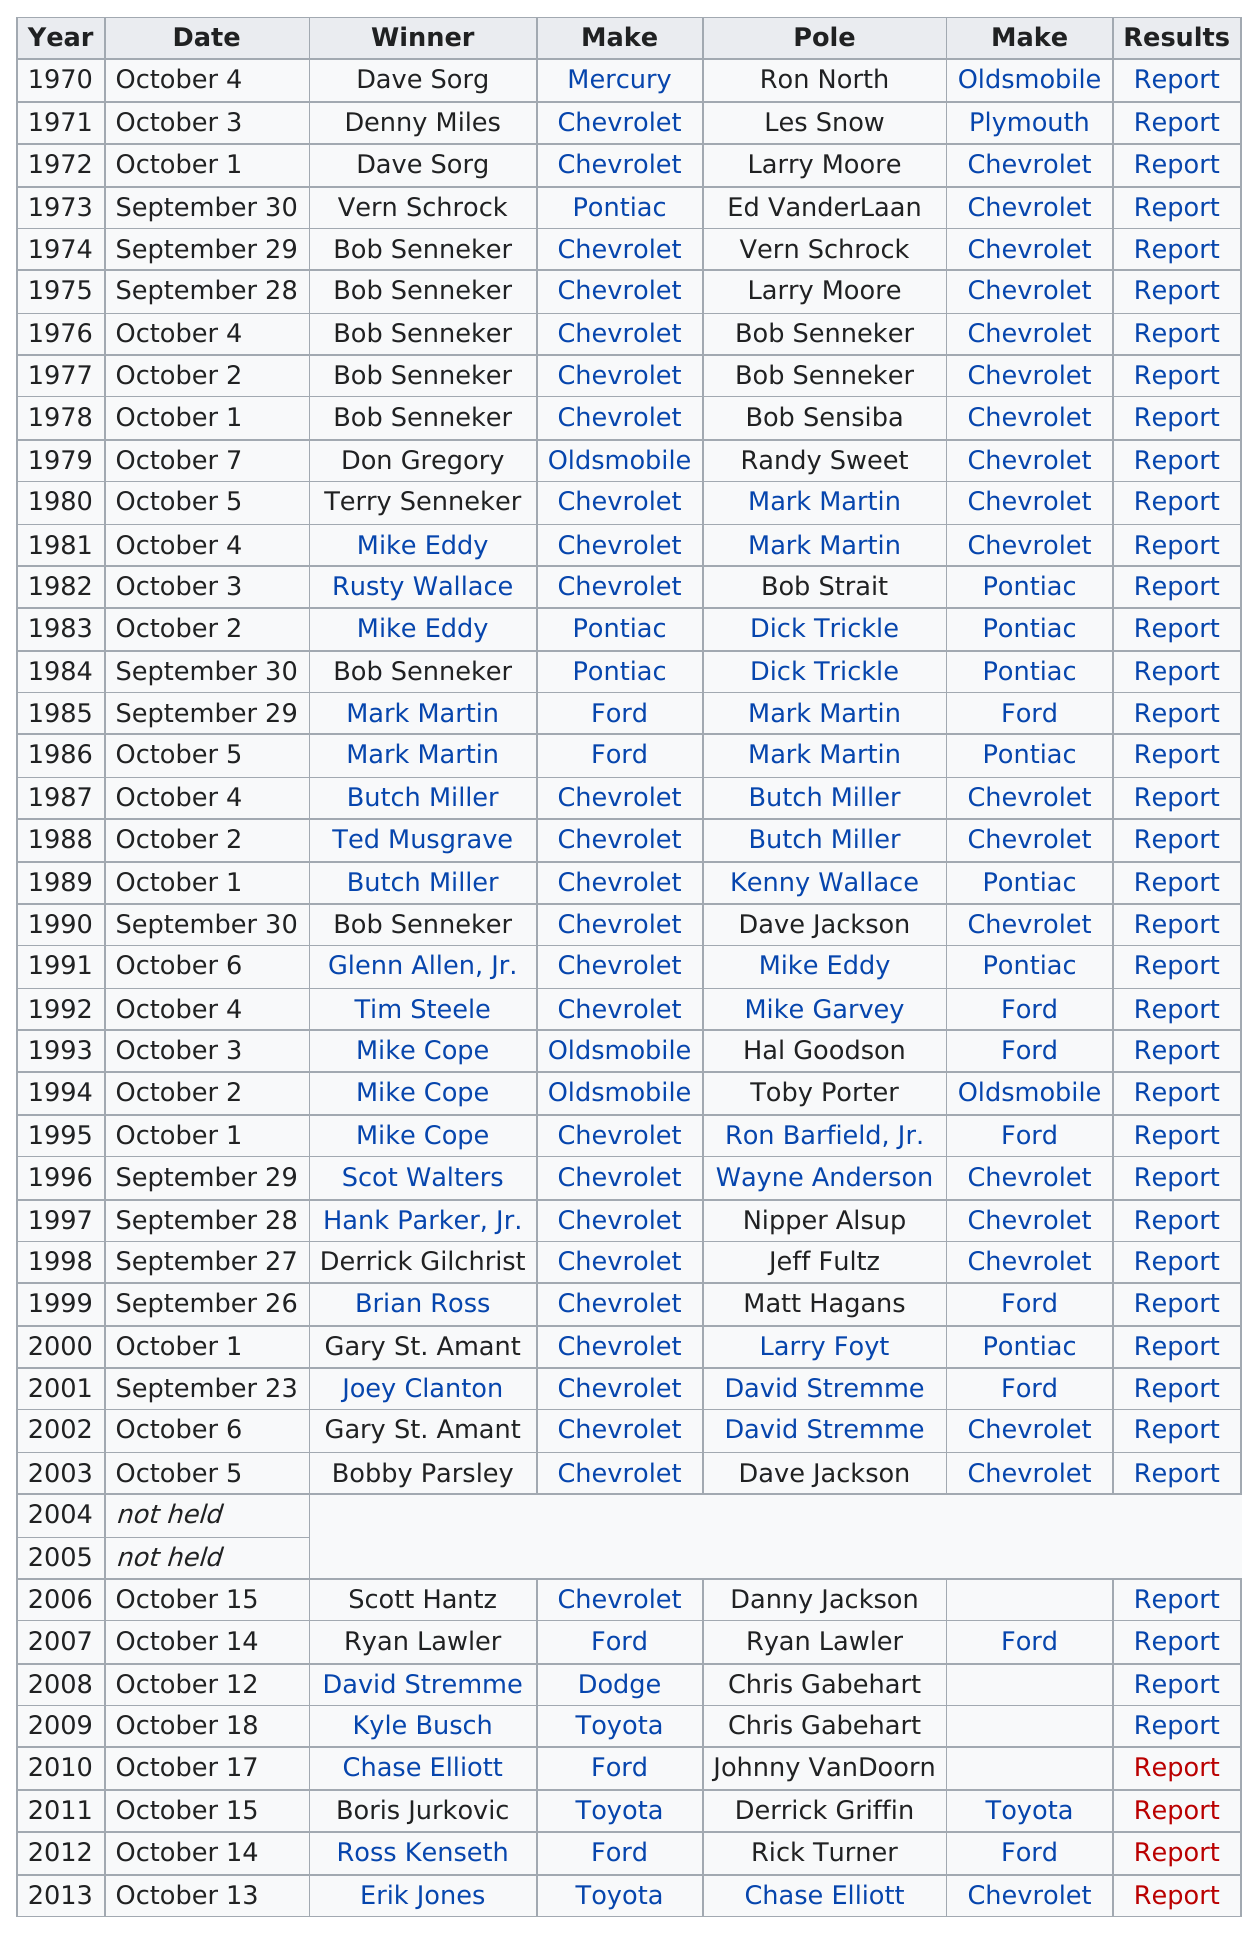Outline some significant characteristics in this image. In October, the most Winchester 400 races were held. How many times did Bob Senneker win in consecutive years? He won five times. Chevrolet has won the most total number of vehicles in the Winchester 400 race. According to the data, Toyota was the make of car that was used the least by those who won races. The player listed after Mike Eddy is Rusty Wallace. 